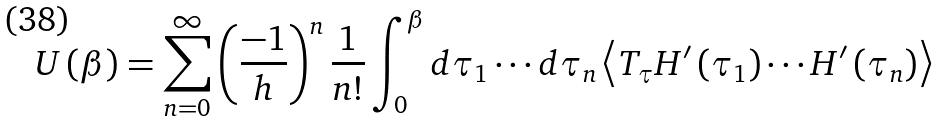Convert formula to latex. <formula><loc_0><loc_0><loc_500><loc_500>U \left ( \beta \right ) = \sum _ { n = 0 } ^ { \infty } \left ( \frac { - 1 } { h } \right ) ^ { n } \frac { 1 } { n ! } \int _ { 0 } ^ { \beta } d \tau _ { 1 } \cdots d \tau _ { n } \left \langle T _ { \tau } H ^ { \prime } \left ( \tau _ { 1 } \right ) \cdots H ^ { \prime } \left ( \tau _ { n } \right ) \right \rangle</formula> 